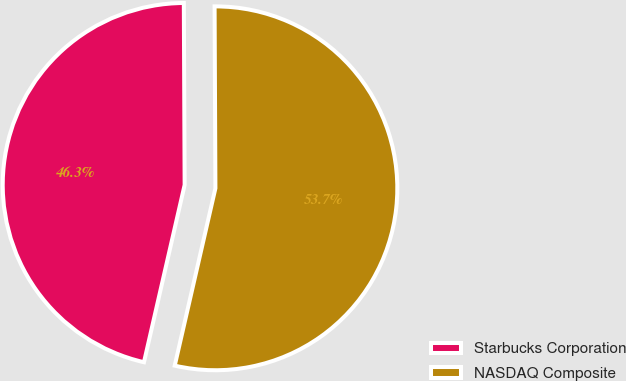Convert chart. <chart><loc_0><loc_0><loc_500><loc_500><pie_chart><fcel>Starbucks Corporation<fcel>NASDAQ Composite<nl><fcel>46.34%<fcel>53.66%<nl></chart> 